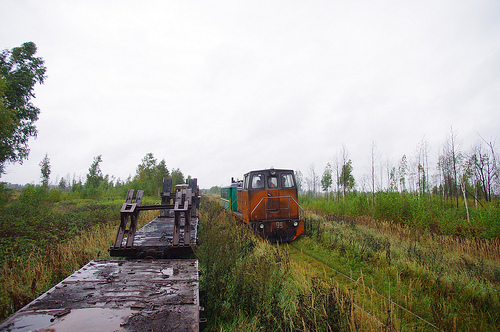How many trains on the train tracks? 1 